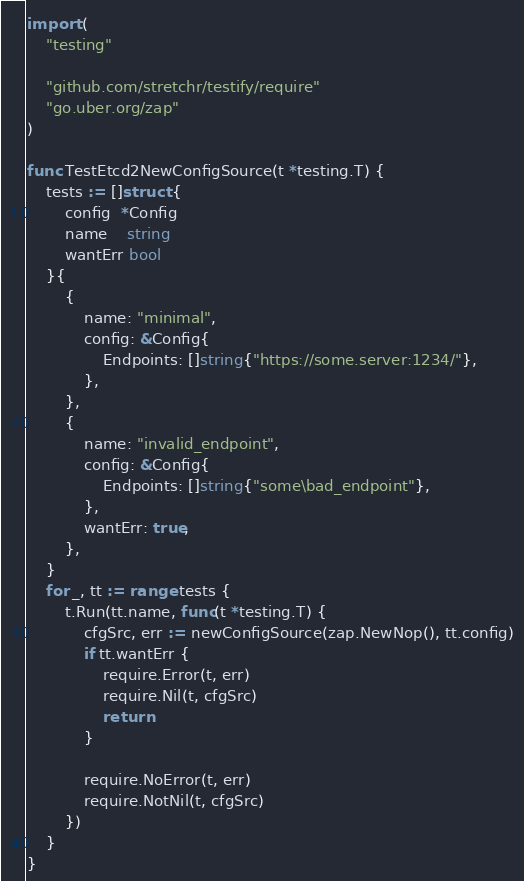Convert code to text. <code><loc_0><loc_0><loc_500><loc_500><_Go_>
import (
	"testing"

	"github.com/stretchr/testify/require"
	"go.uber.org/zap"
)

func TestEtcd2NewConfigSource(t *testing.T) {
	tests := []struct {
		config  *Config
		name    string
		wantErr bool
	}{
		{
			name: "minimal",
			config: &Config{
				Endpoints: []string{"https://some.server:1234/"},
			},
		},
		{
			name: "invalid_endpoint",
			config: &Config{
				Endpoints: []string{"some\bad_endpoint"},
			},
			wantErr: true,
		},
	}
	for _, tt := range tests {
		t.Run(tt.name, func(t *testing.T) {
			cfgSrc, err := newConfigSource(zap.NewNop(), tt.config)
			if tt.wantErr {
				require.Error(t, err)
				require.Nil(t, cfgSrc)
				return
			}

			require.NoError(t, err)
			require.NotNil(t, cfgSrc)
		})
	}
}
</code> 